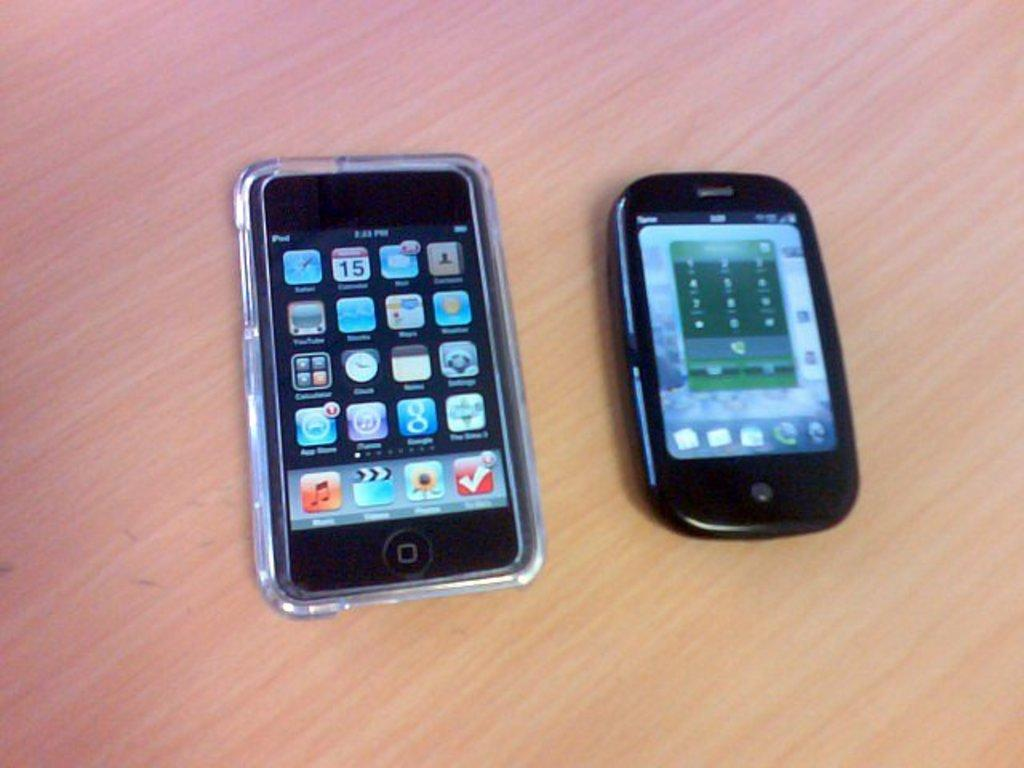Provide a one-sentence caption for the provided image. an iphone in a clear case with the time on it that says '2:23 pm'. 